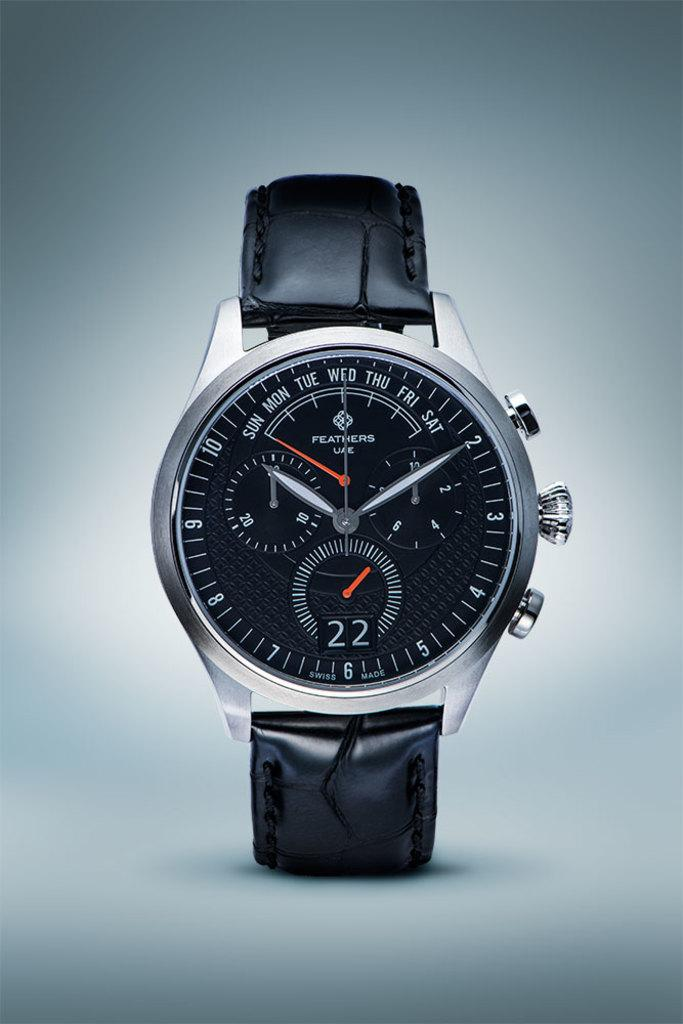<image>
Render a clear and concise summary of the photo. A silver and black watch with the digit 22 on the face. 